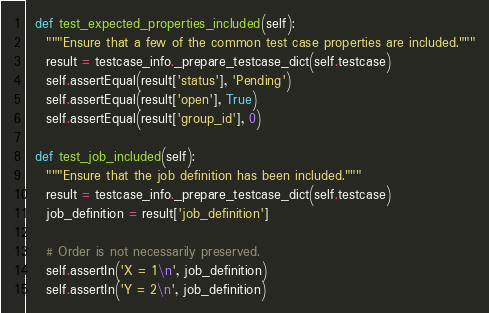<code> <loc_0><loc_0><loc_500><loc_500><_Python_>
  def test_expected_properties_included(self):
    """Ensure that a few of the common test case properties are included."""
    result = testcase_info._prepare_testcase_dict(self.testcase)
    self.assertEqual(result['status'], 'Pending')
    self.assertEqual(result['open'], True)
    self.assertEqual(result['group_id'], 0)

  def test_job_included(self):
    """Ensure that the job definition has been included."""
    result = testcase_info._prepare_testcase_dict(self.testcase)
    job_definition = result['job_definition']

    # Order is not necessarily preserved.
    self.assertIn('X = 1\n', job_definition)
    self.assertIn('Y = 2\n', job_definition)
</code> 